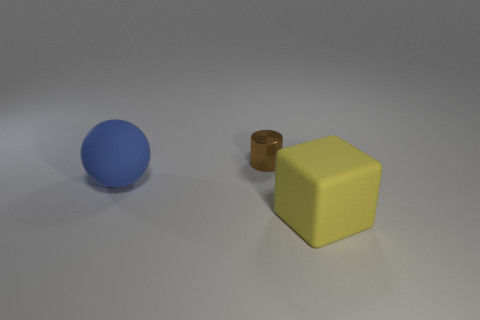Add 2 large yellow rubber blocks. How many objects exist? 5 Subtract all spheres. How many objects are left? 2 Add 2 blue balls. How many blue balls exist? 3 Subtract 1 blue balls. How many objects are left? 2 Subtract all tiny cyan spheres. Subtract all big blue objects. How many objects are left? 2 Add 2 small brown cylinders. How many small brown cylinders are left? 3 